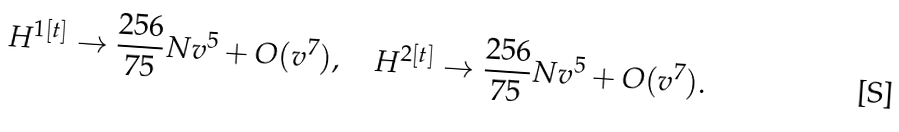Convert formula to latex. <formula><loc_0><loc_0><loc_500><loc_500>H ^ { 1 [ t ] } \rightarrow \frac { 2 5 6 } { 7 5 } N v ^ { 5 } + O ( v ^ { 7 } ) , \quad H ^ { 2 [ t ] } \rightarrow \frac { 2 5 6 } { 7 5 } N v ^ { 5 } + O ( v ^ { 7 } ) .</formula> 